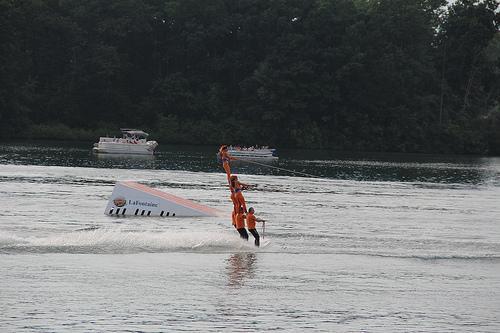How many boats are there visible?
Give a very brief answer. 2. How many boats can be seen in this image?
Give a very brief answer. 2. 